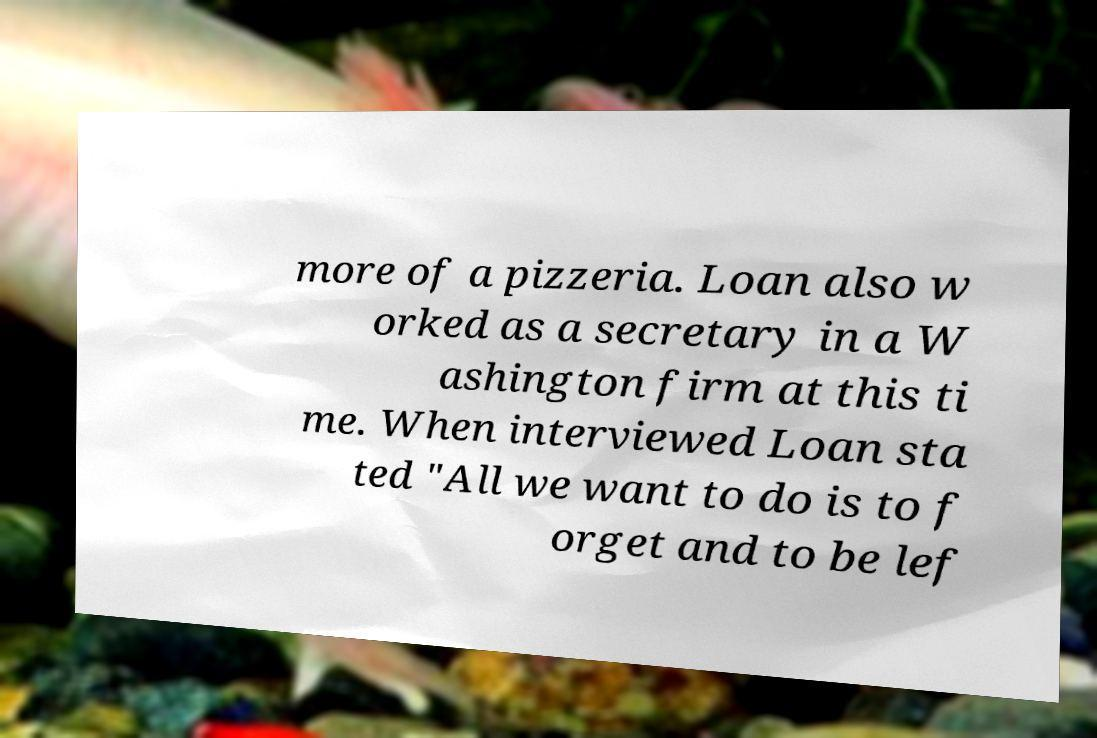For documentation purposes, I need the text within this image transcribed. Could you provide that? more of a pizzeria. Loan also w orked as a secretary in a W ashington firm at this ti me. When interviewed Loan sta ted "All we want to do is to f orget and to be lef 